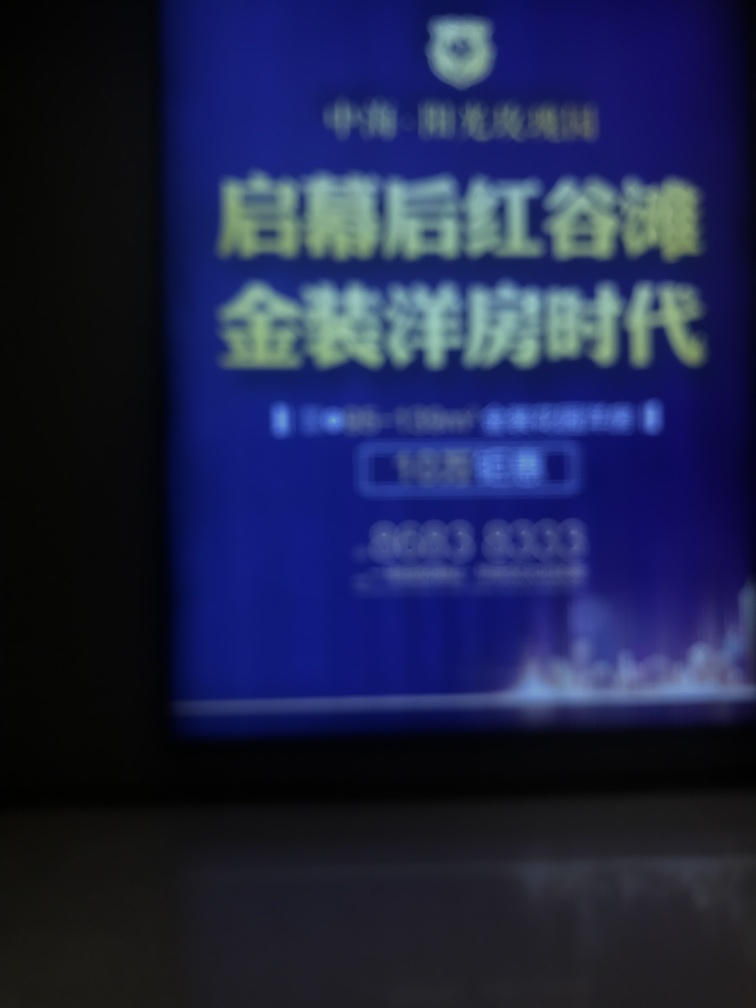Assuming the content in the image was legible, what context or setting does this kind of image seem to fit into? If the text were legible, such an image might be found in contexts such as an advertisement, informational display, or signboard typically used for communication in public spaces or businesses. 